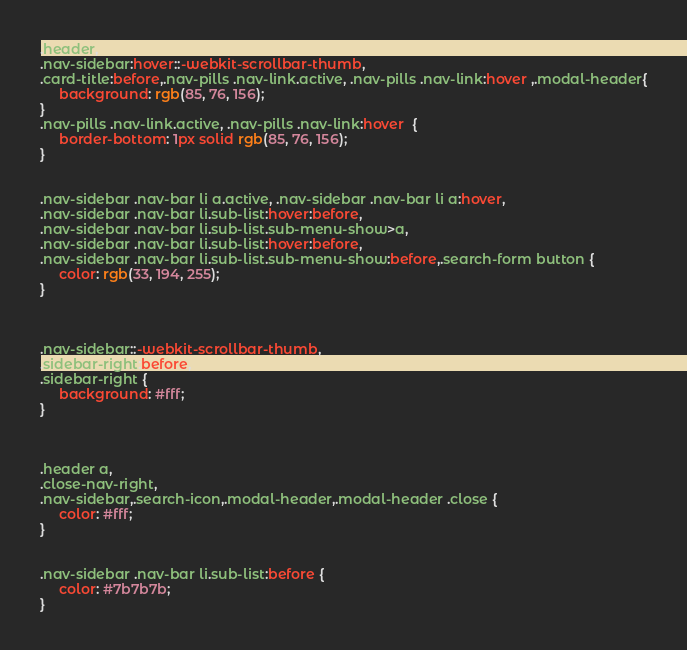Convert code to text. <code><loc_0><loc_0><loc_500><loc_500><_CSS_>



.header,
.nav-sidebar:hover::-webkit-scrollbar-thumb,
.card-title:before,.nav-pills .nav-link.active, .nav-pills .nav-link:hover ,.modal-header{
     background: rgb(85, 76, 156);
}
.nav-pills .nav-link.active, .nav-pills .nav-link:hover  {
     border-bottom: 1px solid rgb(85, 76, 156);
}


.nav-sidebar .nav-bar li a.active, .nav-sidebar .nav-bar li a:hover,
.nav-sidebar .nav-bar li.sub-list:hover:before,
.nav-sidebar .nav-bar li.sub-list.sub-menu-show>a,
.nav-sidebar .nav-bar li.sub-list:hover:before,
.nav-sidebar .nav-bar li.sub-list.sub-menu-show:before,.search-form button {
     color: rgb(33, 194, 255);
}



.nav-sidebar::-webkit-scrollbar-thumb,
.sidebar-right:before,
.sidebar-right {
     background: #fff;
}



.header a,
.close-nav-right,
.nav-sidebar,.search-icon,.modal-header,.modal-header .close {
     color: #fff;
}


.nav-sidebar .nav-bar li.sub-list:before {
     color: #7b7b7b;
}</code> 